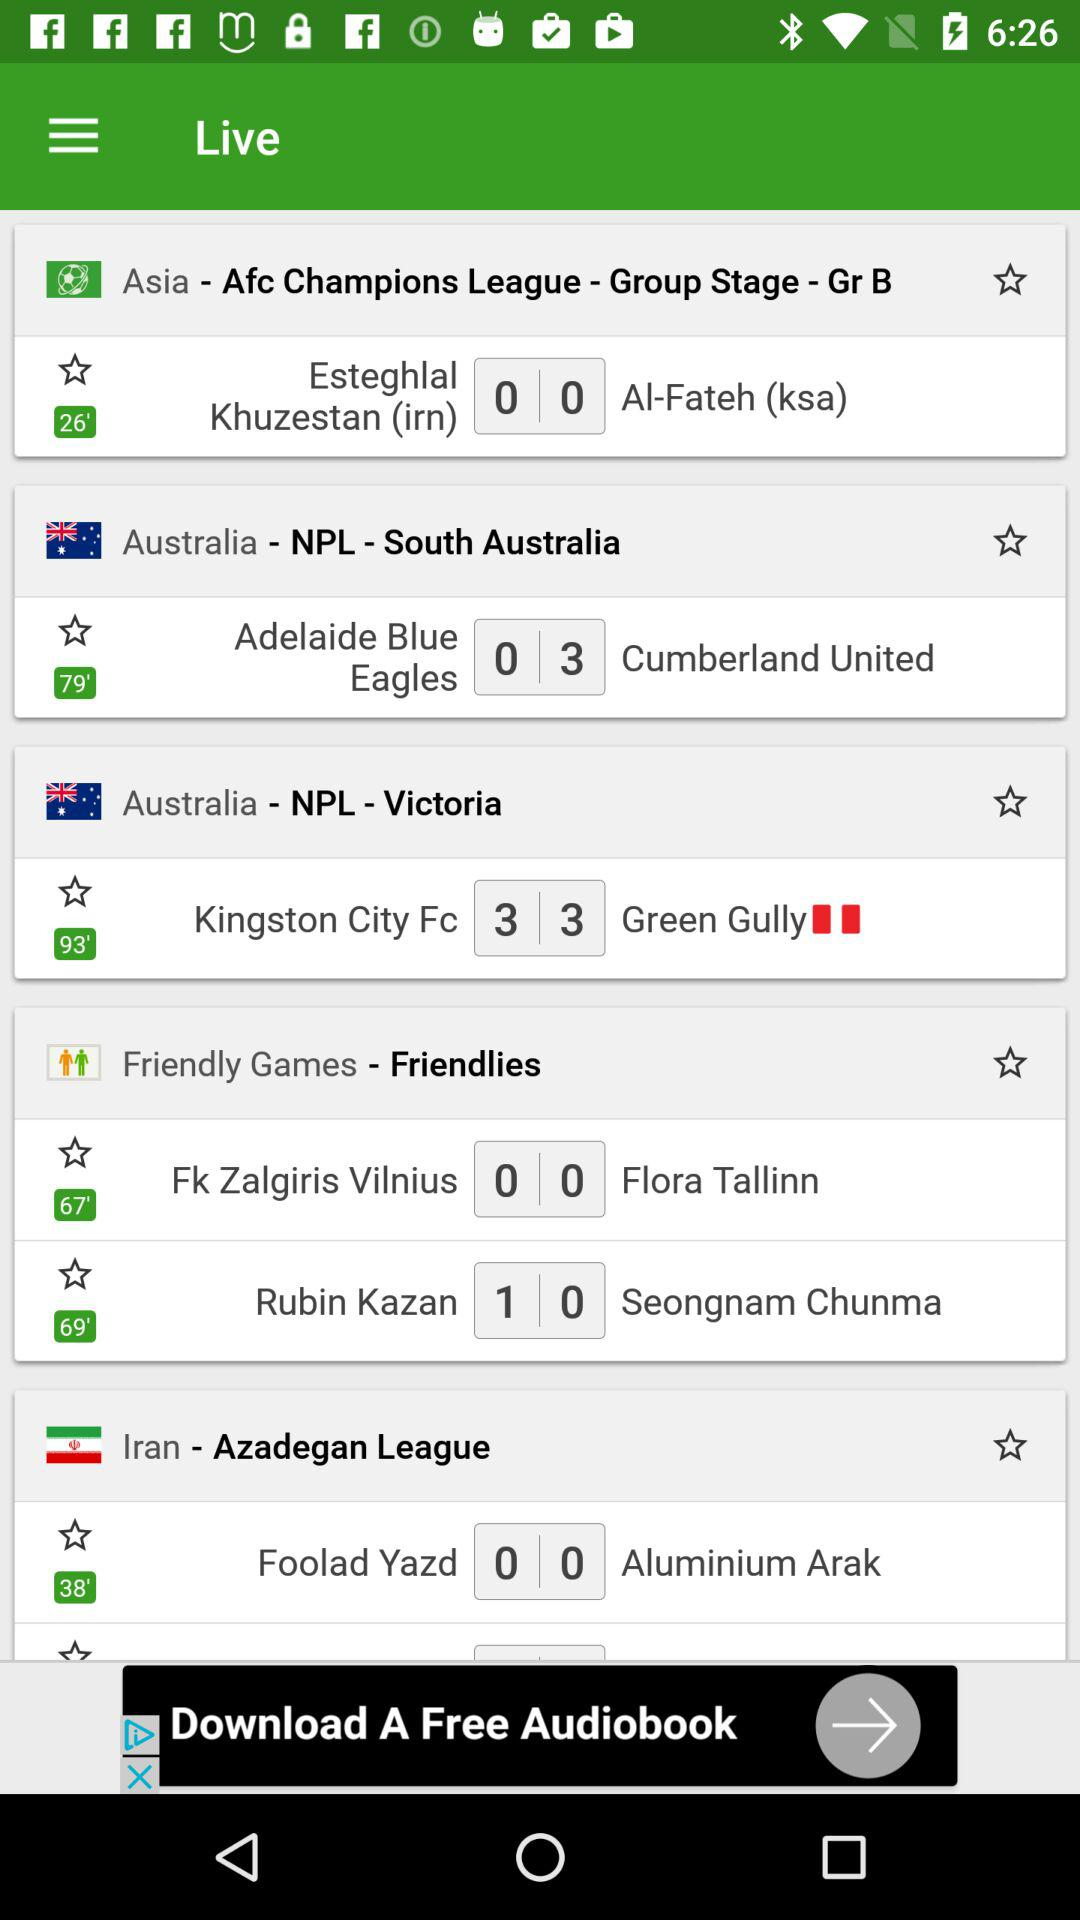What is the score of two teams in the NPL Victoria? The scores of two teams in the NPL Victoria are 3 and 3. 